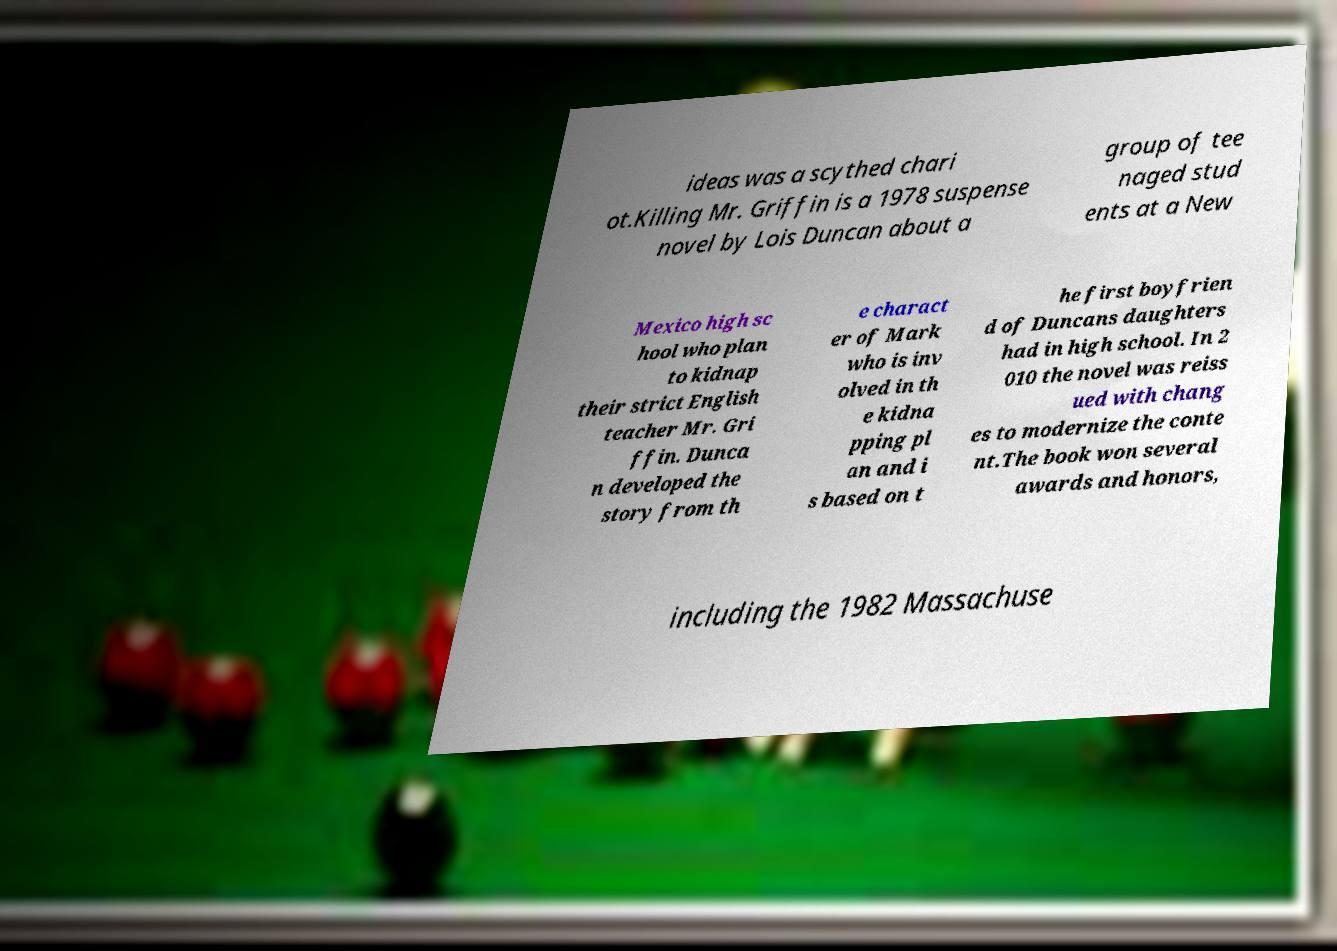There's text embedded in this image that I need extracted. Can you transcribe it verbatim? ideas was a scythed chari ot.Killing Mr. Griffin is a 1978 suspense novel by Lois Duncan about a group of tee naged stud ents at a New Mexico high sc hool who plan to kidnap their strict English teacher Mr. Gri ffin. Dunca n developed the story from th e charact er of Mark who is inv olved in th e kidna pping pl an and i s based on t he first boyfrien d of Duncans daughters had in high school. In 2 010 the novel was reiss ued with chang es to modernize the conte nt.The book won several awards and honors, including the 1982 Massachuse 